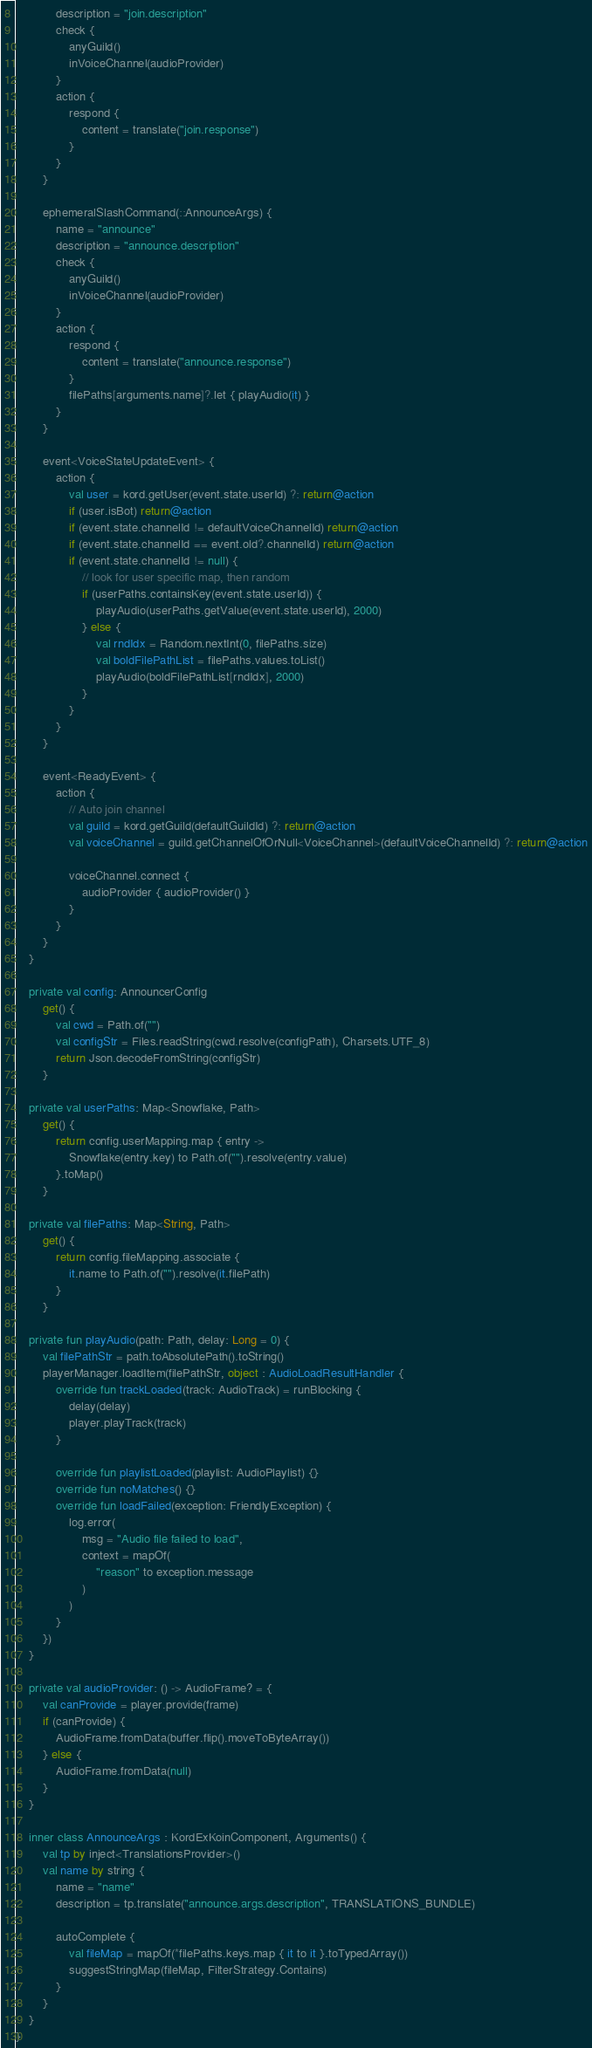Convert code to text. <code><loc_0><loc_0><loc_500><loc_500><_Kotlin_>            description = "join.description"
            check {
                anyGuild()
                inVoiceChannel(audioProvider)
            }
            action {
                respond {
                    content = translate("join.response")
                }
            }
        }

        ephemeralSlashCommand(::AnnounceArgs) {
            name = "announce"
            description = "announce.description"
            check {
                anyGuild()
                inVoiceChannel(audioProvider)
            }
            action {
                respond {
                    content = translate("announce.response")
                }
                filePaths[arguments.name]?.let { playAudio(it) }
            }
        }

        event<VoiceStateUpdateEvent> {
            action {
                val user = kord.getUser(event.state.userId) ?: return@action
                if (user.isBot) return@action
                if (event.state.channelId != defaultVoiceChannelId) return@action
                if (event.state.channelId == event.old?.channelId) return@action
                if (event.state.channelId != null) {
                    // look for user specific map, then random
                    if (userPaths.containsKey(event.state.userId)) {
                        playAudio(userPaths.getValue(event.state.userId), 2000)
                    } else {
                        val rndIdx = Random.nextInt(0, filePaths.size)
                        val boldFilePathList = filePaths.values.toList()
                        playAudio(boldFilePathList[rndIdx], 2000)
                    }
                }
            }
        }

        event<ReadyEvent> {
            action {
                // Auto join channel
                val guild = kord.getGuild(defaultGuildId) ?: return@action
                val voiceChannel = guild.getChannelOfOrNull<VoiceChannel>(defaultVoiceChannelId) ?: return@action

                voiceChannel.connect {
                    audioProvider { audioProvider() }
                }
            }
        }
    }

    private val config: AnnouncerConfig
        get() {
            val cwd = Path.of("")
            val configStr = Files.readString(cwd.resolve(configPath), Charsets.UTF_8)
            return Json.decodeFromString(configStr)
        }

    private val userPaths: Map<Snowflake, Path>
        get() {
            return config.userMapping.map { entry ->
                Snowflake(entry.key) to Path.of("").resolve(entry.value)
            }.toMap()
        }

    private val filePaths: Map<String, Path>
        get() {
            return config.fileMapping.associate {
                it.name to Path.of("").resolve(it.filePath)
            }
        }

    private fun playAudio(path: Path, delay: Long = 0) {
        val filePathStr = path.toAbsolutePath().toString()
        playerManager.loadItem(filePathStr, object : AudioLoadResultHandler {
            override fun trackLoaded(track: AudioTrack) = runBlocking {
                delay(delay)
                player.playTrack(track)
            }

            override fun playlistLoaded(playlist: AudioPlaylist) {}
            override fun noMatches() {}
            override fun loadFailed(exception: FriendlyException) {
                log.error(
                    msg = "Audio file failed to load",
                    context = mapOf(
                        "reason" to exception.message
                    )
                )
            }
        })
    }

    private val audioProvider: () -> AudioFrame? = {
        val canProvide = player.provide(frame)
        if (canProvide) {
            AudioFrame.fromData(buffer.flip().moveToByteArray())
        } else {
            AudioFrame.fromData(null)
        }
    }

    inner class AnnounceArgs : KordExKoinComponent, Arguments() {
        val tp by inject<TranslationsProvider>()
        val name by string {
            name = "name"
            description = tp.translate("announce.args.description", TRANSLATIONS_BUNDLE)

            autoComplete {
                val fileMap = mapOf(*filePaths.keys.map { it to it }.toTypedArray())
                suggestStringMap(fileMap, FilterStrategy.Contains)
            }
        }
    }
}</code> 